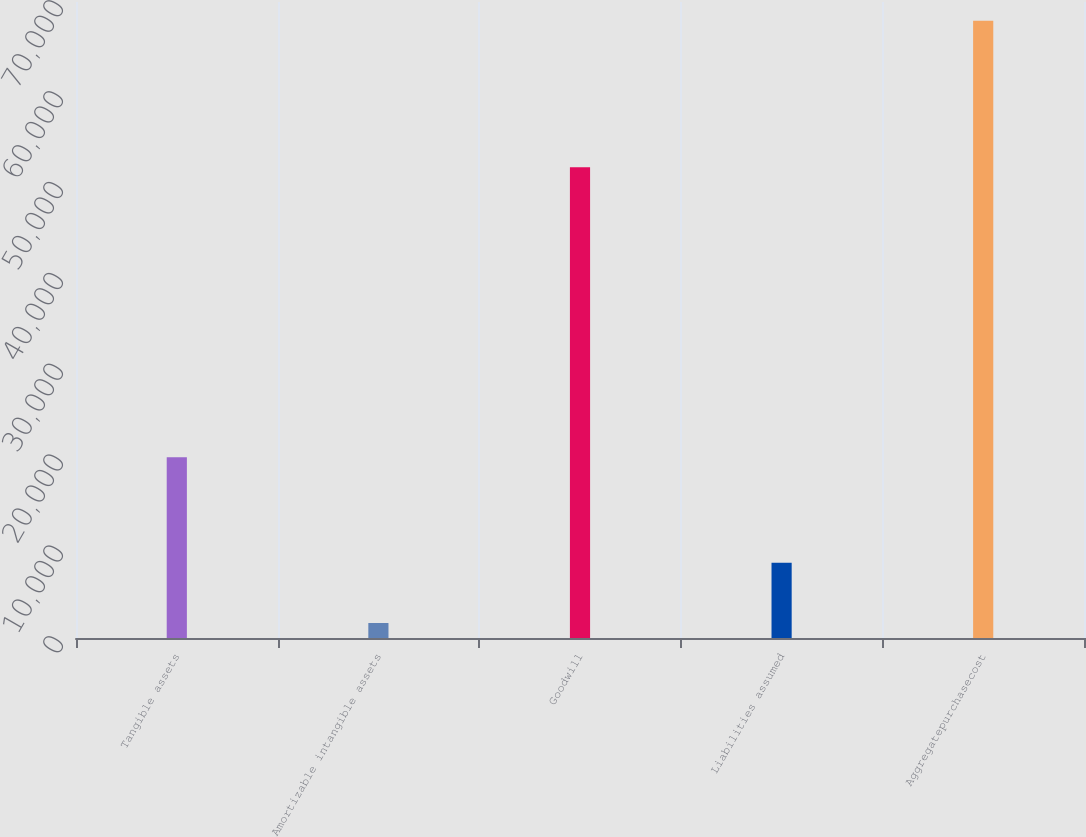Convert chart to OTSL. <chart><loc_0><loc_0><loc_500><loc_500><bar_chart><fcel>Tangible assets<fcel>Amortizable intangible assets<fcel>Goodwill<fcel>Liabilities assumed<fcel>Aggregatepurchasecost<nl><fcel>19886<fcel>1648<fcel>51820<fcel>8278.2<fcel>67950<nl></chart> 